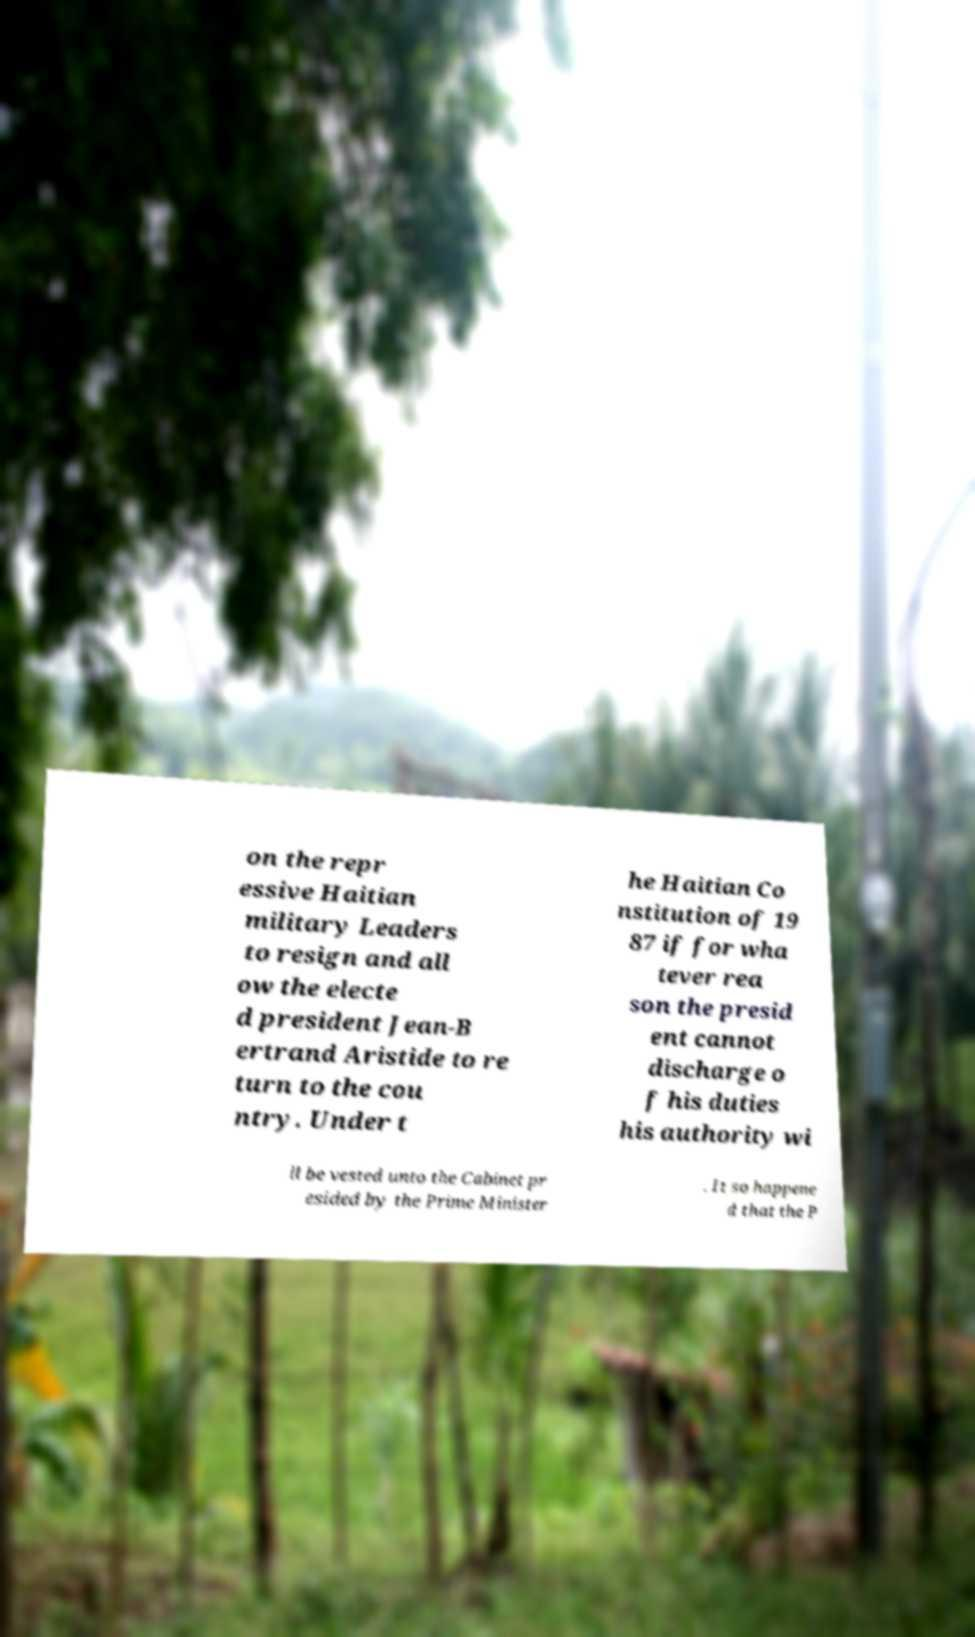Can you read and provide the text displayed in the image?This photo seems to have some interesting text. Can you extract and type it out for me? on the repr essive Haitian military Leaders to resign and all ow the electe d president Jean-B ertrand Aristide to re turn to the cou ntry. Under t he Haitian Co nstitution of 19 87 if for wha tever rea son the presid ent cannot discharge o f his duties his authority wi ll be vested unto the Cabinet pr esided by the Prime Minister . It so happene d that the P 